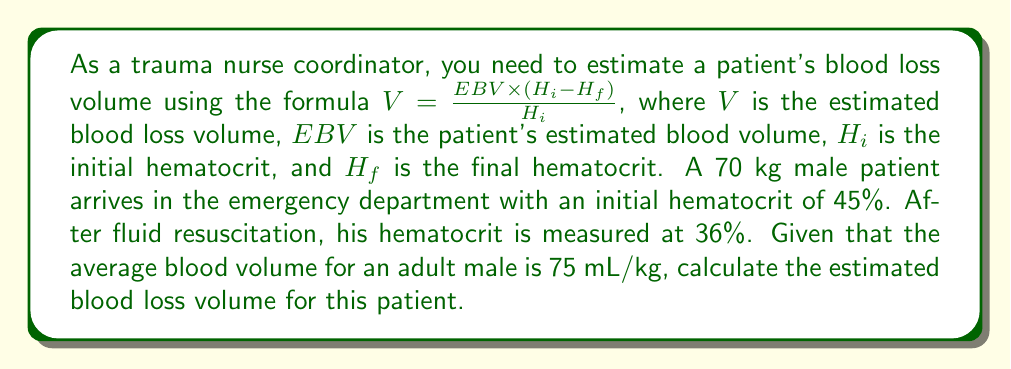Solve this math problem. To solve this problem, we'll follow these steps:

1. Calculate the patient's estimated blood volume (EBV):
   $EBV = 70 \text{ kg} \times 75 \text{ mL/kg} = 5250 \text{ mL}$

2. Identify the values for the formula:
   $EBV = 5250 \text{ mL}$
   $H_i = 45\% = 0.45$
   $H_f = 36\% = 0.36$

3. Apply the formula:
   $$V = \frac{EBV \times (H_i - H_f)}{H_i}$$
   $$V = \frac{5250 \times (0.45 - 0.36)}{0.45}$$

4. Calculate:
   $$V = \frac{5250 \times 0.09}{0.45}$$
   $$V = \frac{472.5}{0.45}$$
   $$V = 1050 \text{ mL}$$

Therefore, the estimated blood loss volume for this patient is 1050 mL.
Answer: 1050 mL 